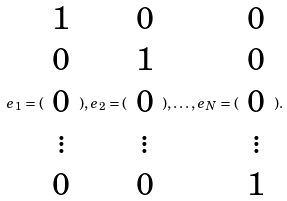Convert formula to latex. <formula><loc_0><loc_0><loc_500><loc_500>e _ { 1 } = ( \begin{array} { c } 1 \\ 0 \\ 0 \\ \vdots \\ 0 \end{array} ) , e _ { 2 } = ( \begin{array} { c } 0 \\ 1 \\ 0 \\ \vdots \\ 0 \end{array} ) , \dots , e _ { N } = ( \begin{array} { c } 0 \\ 0 \\ 0 \\ \vdots \\ 1 \end{array} ) .</formula> 